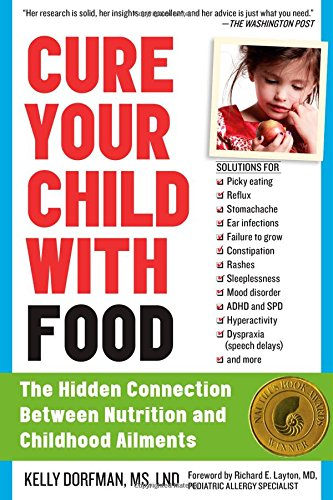What is the title of this book? The title of the book shown is 'Cure Your Child with Food: The Hidden Connection Between Nutrition and Childhood Ailments,' highlighting the focus on dietary solutions for children's medical conditions. 